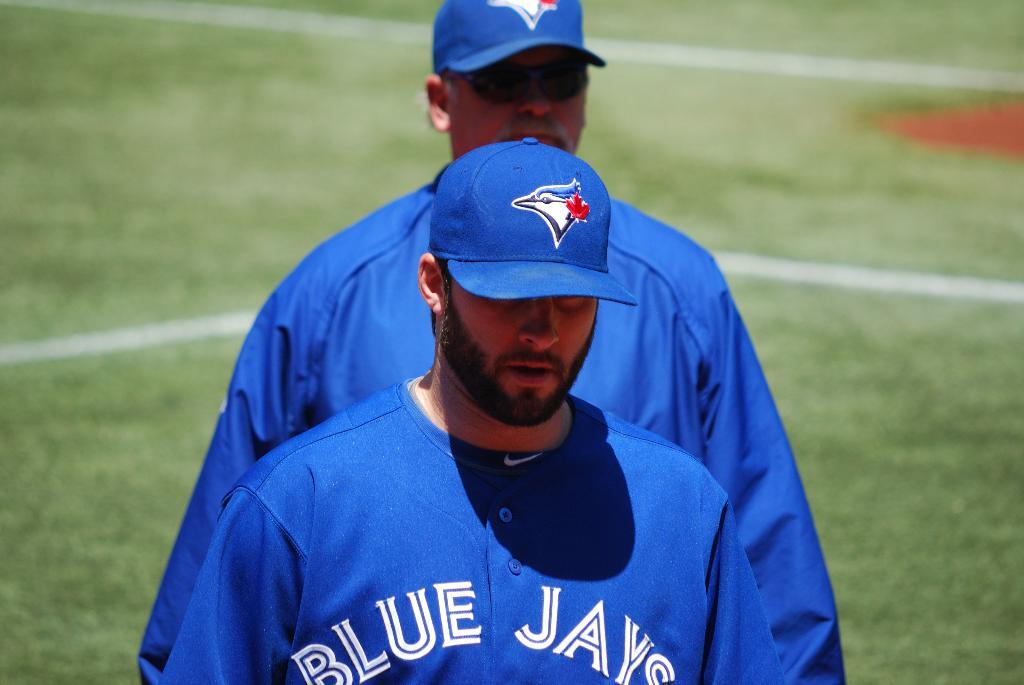<image>
Share a concise interpretation of the image provided. Man wearing a blue Blue Jays jersey out on the grass. 